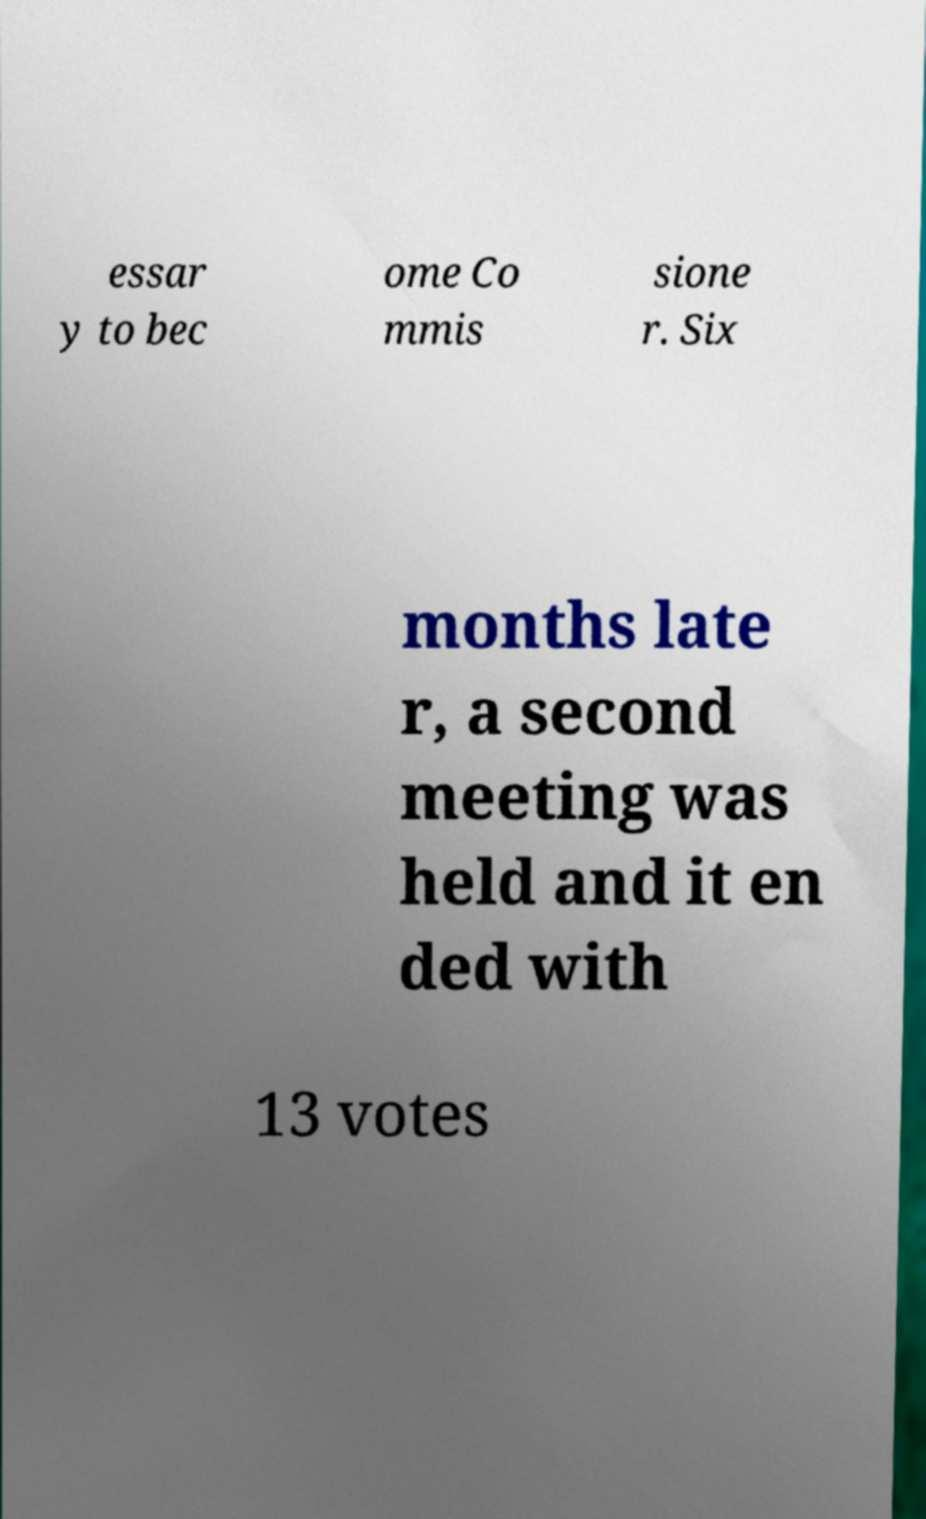Please read and relay the text visible in this image. What does it say? essar y to bec ome Co mmis sione r. Six months late r, a second meeting was held and it en ded with 13 votes 